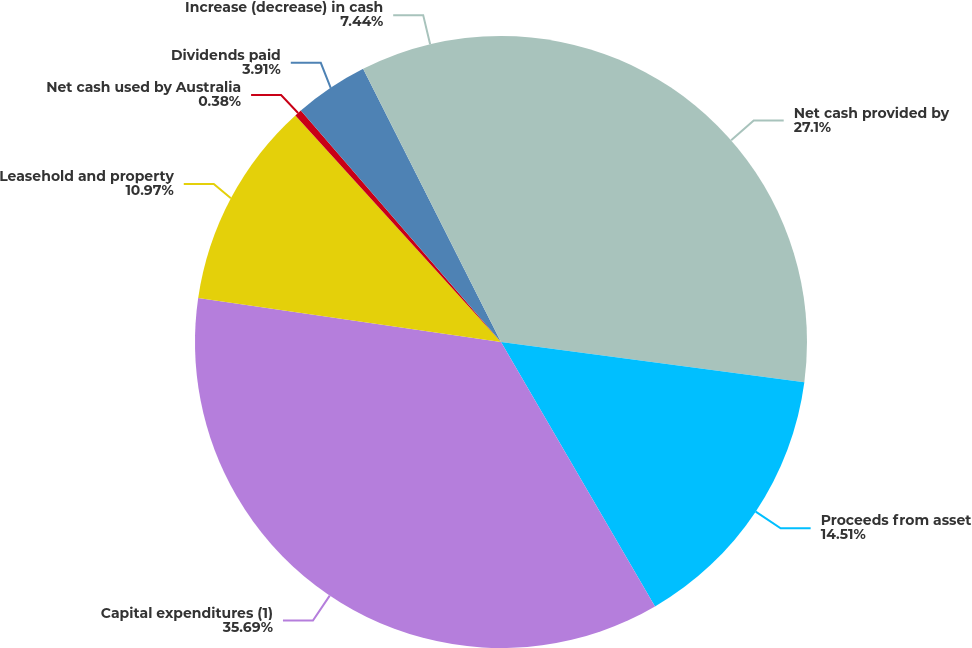<chart> <loc_0><loc_0><loc_500><loc_500><pie_chart><fcel>Net cash provided by<fcel>Proceeds from asset<fcel>Capital expenditures (1)<fcel>Leasehold and property<fcel>Net cash used by Australia<fcel>Dividends paid<fcel>Increase (decrease) in cash<nl><fcel>27.1%<fcel>14.51%<fcel>35.7%<fcel>10.97%<fcel>0.38%<fcel>3.91%<fcel>7.44%<nl></chart> 